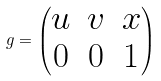Convert formula to latex. <formula><loc_0><loc_0><loc_500><loc_500>g = \begin{pmatrix} u & v & x \\ 0 & 0 & 1 \end{pmatrix}</formula> 